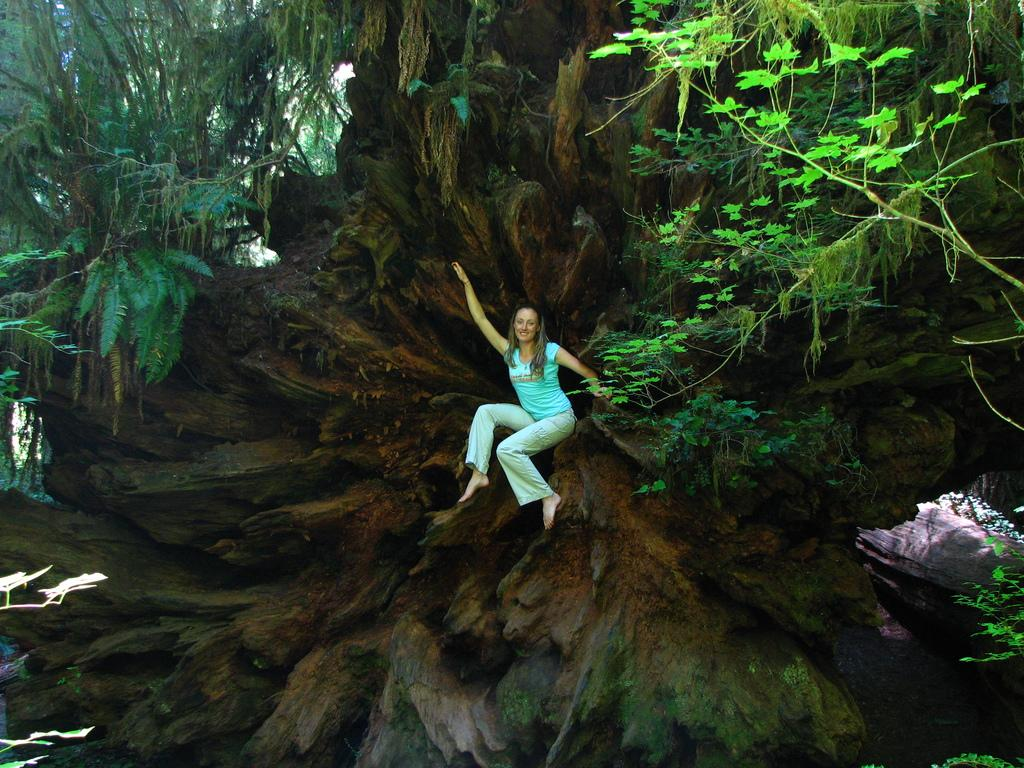Who is the main subject in the image? There is a woman in the picture. What is the woman doing in the image? The woman is sitting on a branch of a tree. What type of environment is depicted in the image? There are trees present in the image. What grade did the stranger give the woman for her performance in the image? There is no stranger present in the image, and therefore no performance or grade can be assessed. 